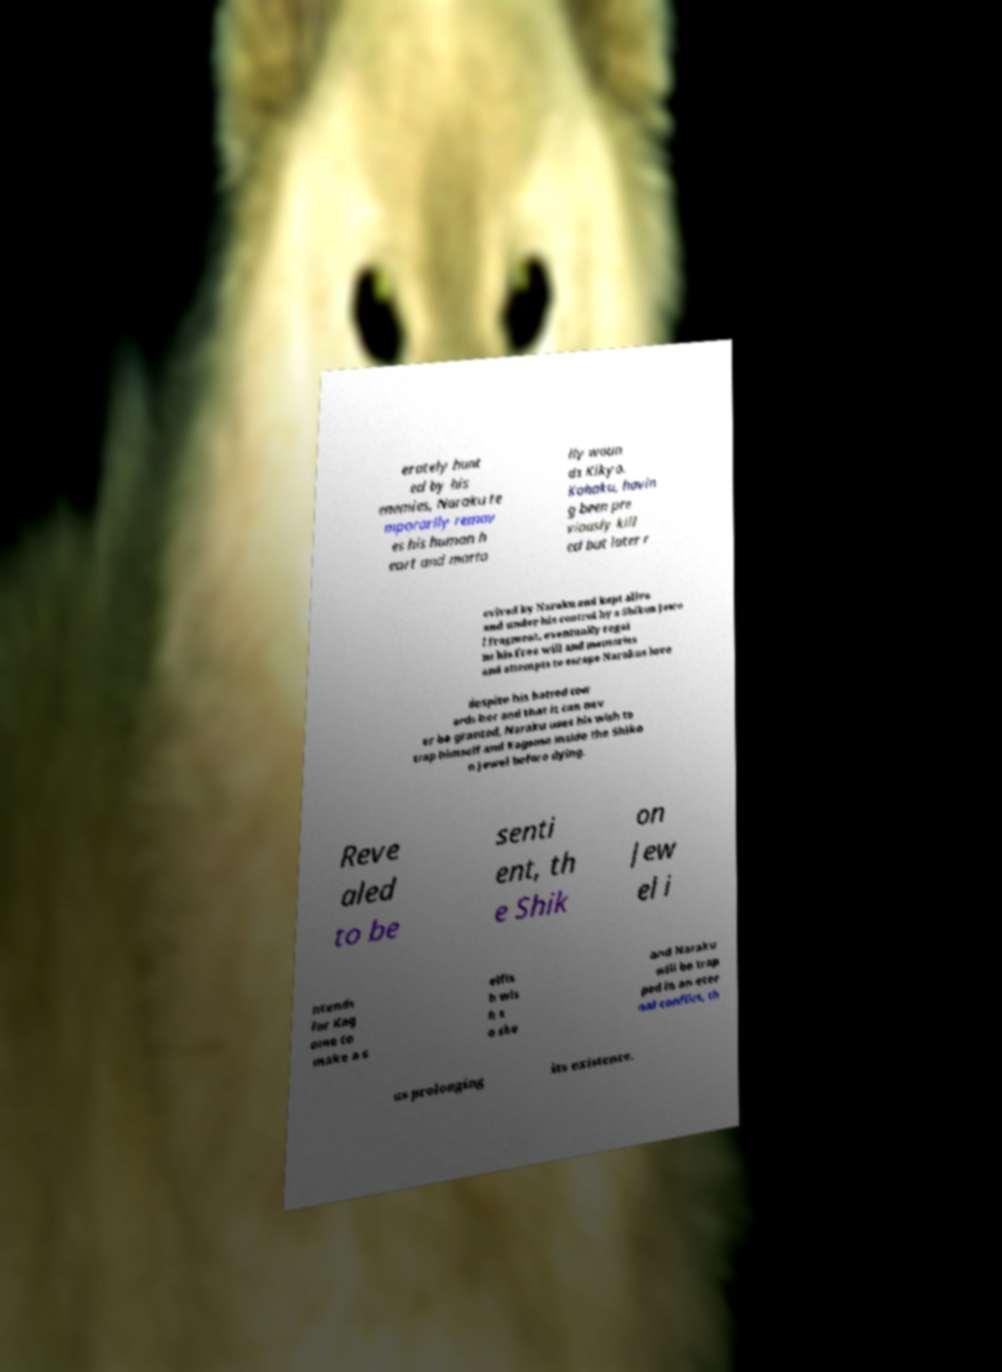What messages or text are displayed in this image? I need them in a readable, typed format. erately hunt ed by his enemies, Naraku te mporarily remov es his human h eart and morta lly woun ds Kikyo. Kohaku, havin g been pre viously kill ed but later r evived by Naraku and kept alive and under his control by a Shikon Jewe l fragment, eventually regai ns his free will and memories and attempts to escape Narakus love despite his hatred tow ards her and that it can nev er be granted, Naraku uses his wish to trap himself and Kagome inside the Shiko n Jewel before dying. Reve aled to be senti ent, th e Shik on Jew el i ntends for Kag ome to make a s elfis h wis h s o she and Naraku will be trap ped in an eter nal conflict, th us prolonging its existence. 